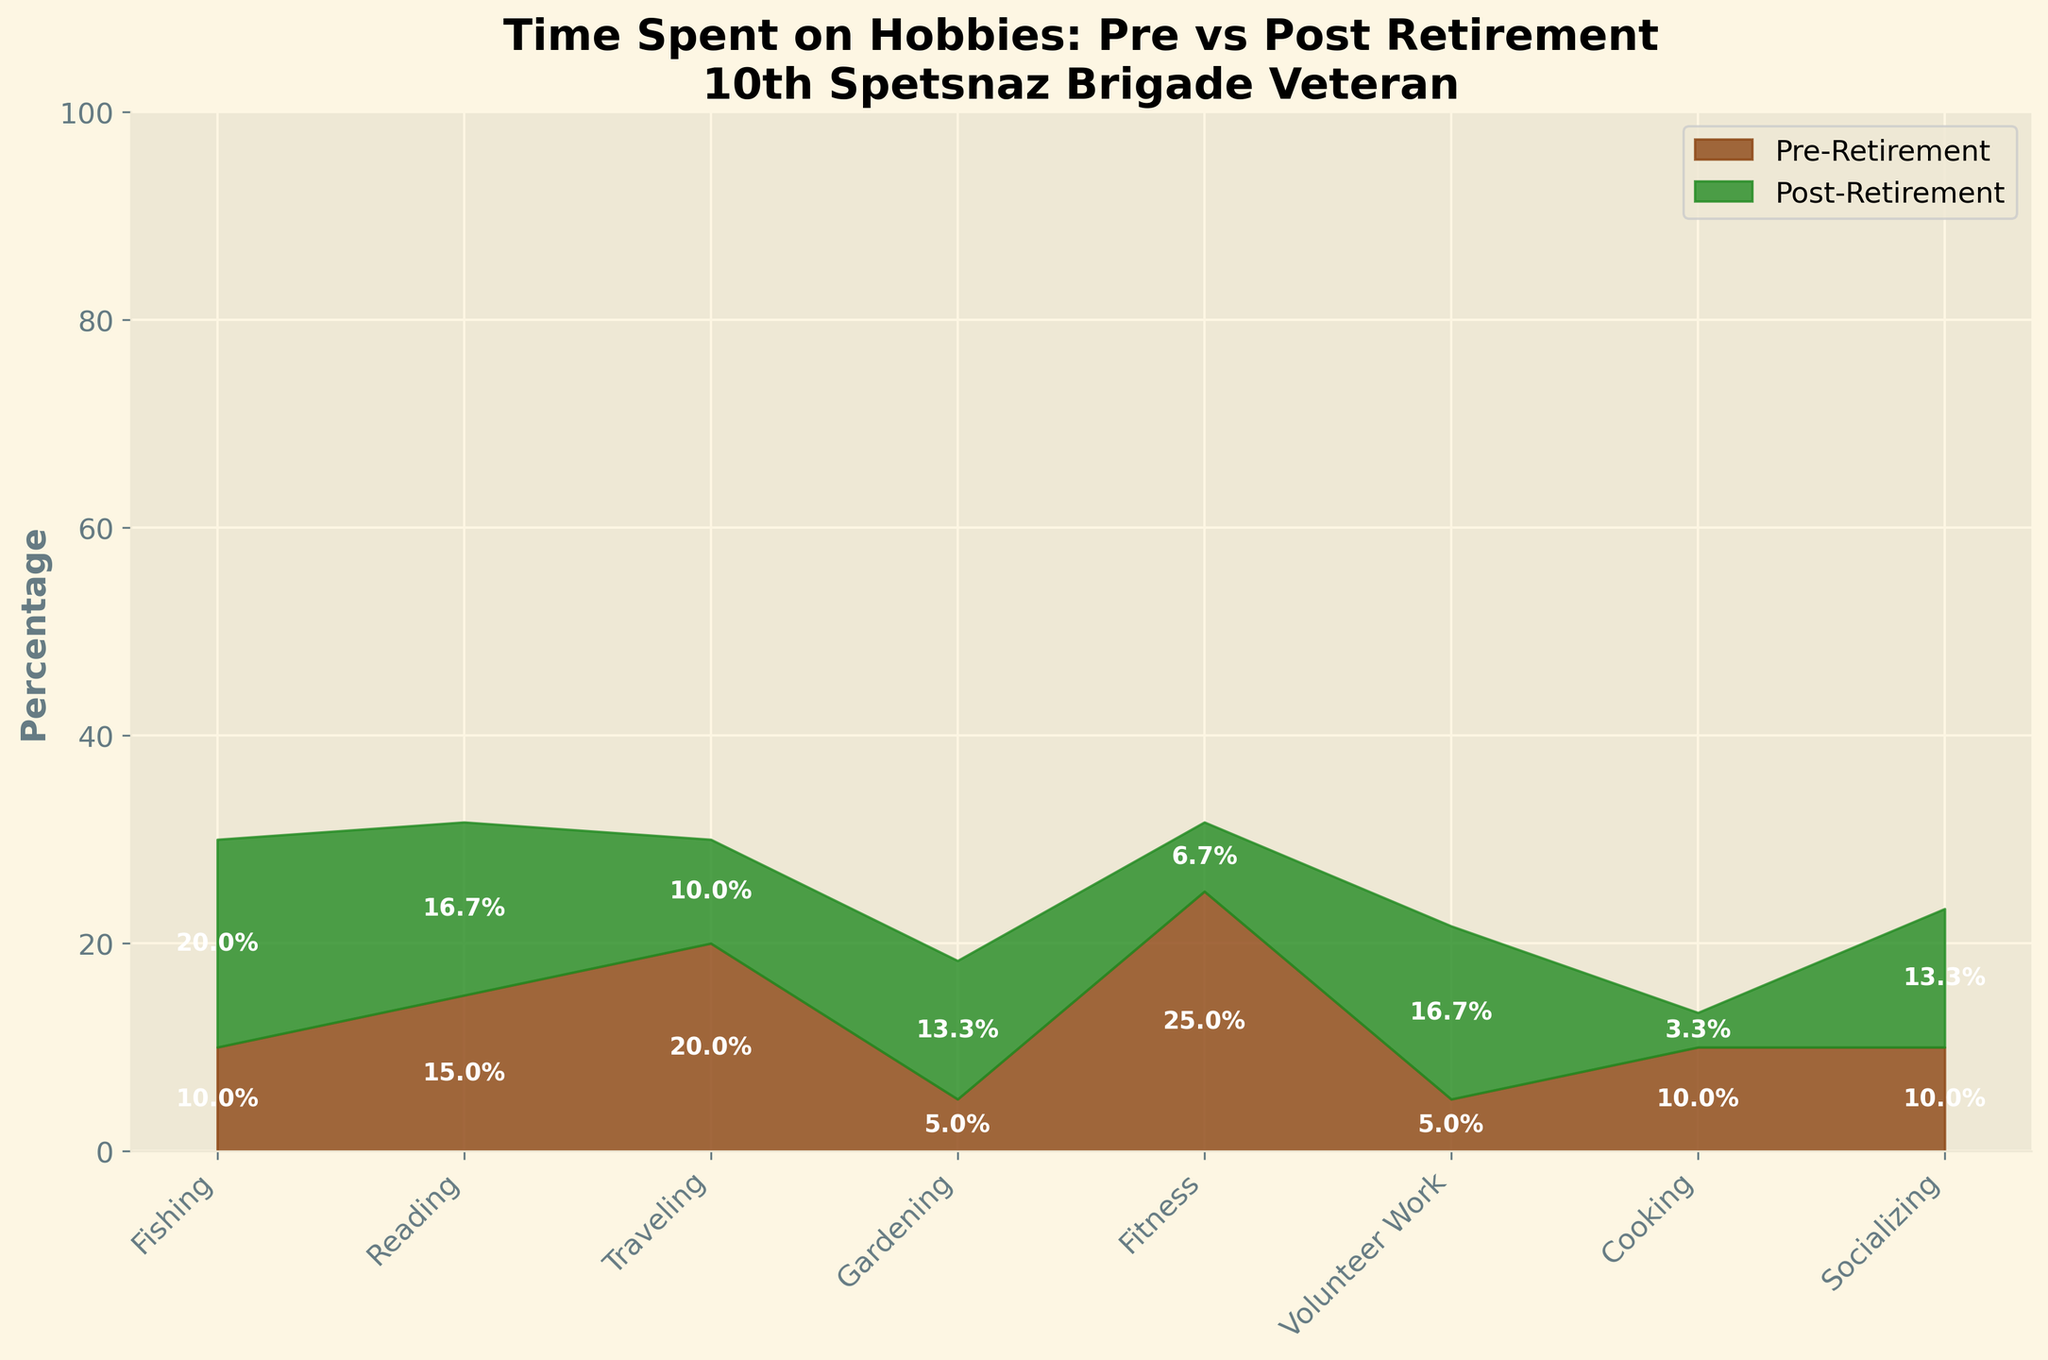what are the two main segments shown in the chart? The chart uses two main segments to differentiate time spent on hobbies: "Pre-Retirement" and "Post-Retirement". The segments are visually distinguished using different colors and a stack format.
Answer: Pre-Retirement and Post-Retirement What hobby took the most time pre-retirement? To find the hobby that took the most time pre-retirement, look for the segment with the highest percentage before retirement. This is "Fitness" with 25%.
Answer: Fitness What hobby has the highest increase in time spent post-retirement? We need to calculate the difference between the pre-retirement and post-retirement percentages for each category. "Volunteer Work" increases from 5% to 25%, which is the highest increase.
Answer: Volunteer Work Which color represents post-retirement activities? In the figure, post-retirement activities are shown in green, while pre-retirement activities are in brown.
Answer: Green Which hobby decreased the most in time spent after retirement compared to before? Compare the percentage values for pre- and post-retirement. "Fitness" decreased from 25% to 10%, which is the largest reduction.
Answer: Fitness How has socializing time changed from pre-retirement to post-retirement? Socializing increased from 10% pre-retirement to 20% post-retirement. This is an increase of 10%.
Answer: Increased by 10% What percentage of time was spent on cooking post-retirement? The target percentage can be directly read from the chart. Post-retirement time spent on cooking is 5%.
Answer: 5% Which hobbies have equal percentages of time spent in both pre- and post-retirement? By visually comparing the chart, no hobbies have equal percentages pre- and post-retirement.
Answer: None How does the time spent on gardening compare pre-and post-retirement? Gardening increased from 5% pre-retirement to 20% post-retirement. This shows an increase of 15%.
Answer: Increased by 15% What is the total percentage of time spent on fishing and reading combined, post-retirement? Sum the post-retirement percentages of fishing (30%) and reading (25%). The total is 30% + 25% = 55%.
Answer: 55% 